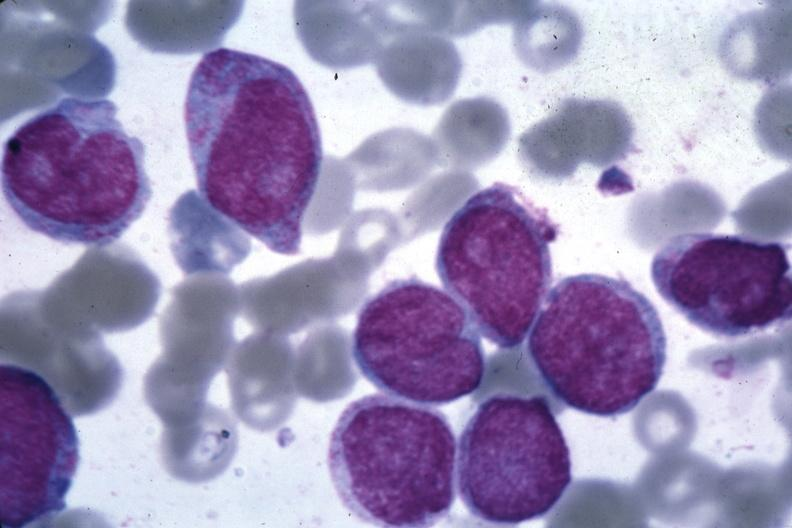s angiogram present?
Answer the question using a single word or phrase. No 